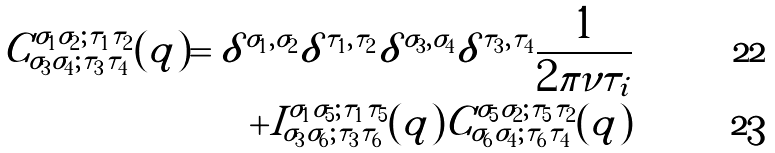Convert formula to latex. <formula><loc_0><loc_0><loc_500><loc_500>C ^ { \sigma _ { 1 } \sigma _ { 2 } ; \tau _ { 1 } \tau _ { 2 } } _ { \sigma _ { 3 } \sigma _ { 4 } ; \tau _ { 3 } \tau _ { 4 } } ( q ) = \delta ^ { \sigma _ { 1 } , \sigma _ { 2 } } \delta ^ { \tau _ { 1 } , \tau _ { 2 } } \delta ^ { \sigma _ { 3 } , \sigma _ { 4 } } \delta ^ { \tau _ { 3 } , \tau _ { 4 } } \frac { 1 } { 2 \pi \nu \tau _ { i } } \\ + I ^ { \sigma _ { 1 } \sigma _ { 5 } ; \tau _ { 1 } \tau _ { 5 } } _ { \sigma _ { 3 } \sigma _ { 6 } ; \tau _ { 3 } \tau _ { 6 } } ( q ) C ^ { \sigma _ { 5 } \sigma _ { 2 } ; \tau _ { 5 } \tau _ { 2 } } _ { \sigma _ { 6 } \sigma _ { 4 } ; \tau _ { 6 } \tau _ { 4 } } ( q )</formula> 